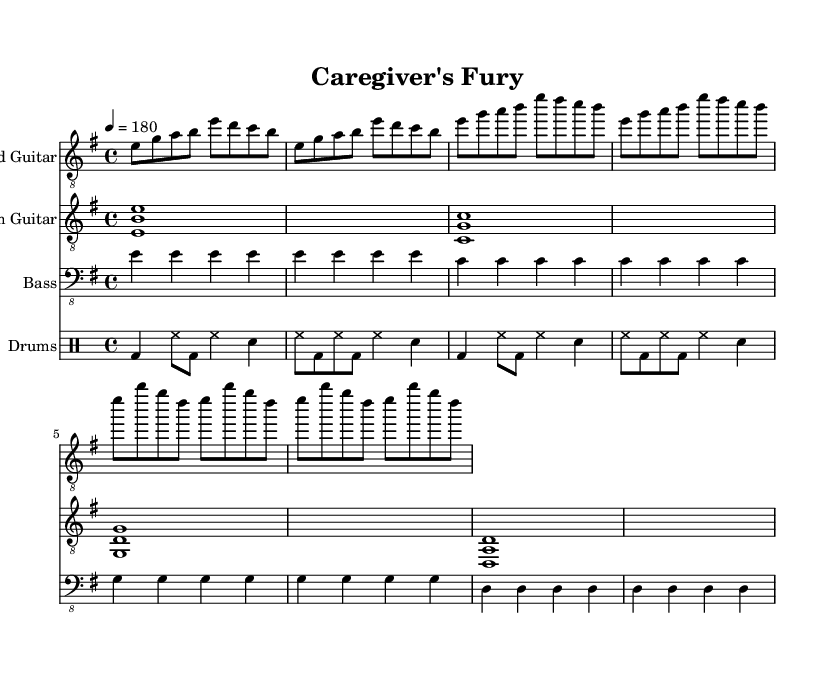What is the key signature of this music? The key signature is E minor, characterized by one sharp (F#). This is evident from the key indication in the global music block.
Answer: E minor What is the time signature of this music? The time signature is 4/4, as indicated in the global music block. This means there are four beats in each measure, and a quarter note receives one beat.
Answer: 4/4 What is the tempo of this piece? The tempo is marked at 180 beats per minute, which signifies a fast-paced performance. This is provided in the global music block as "4 = 180".
Answer: 180 How many measures are there in the lead guitar section? The lead guitar section contains a total of eight measures. This can be counted from the introductory section and two repeated verses, both of which are clearly organized into four measure segments.
Answer: Eight What is the dynamic characteristic of this piece based on its structure? The dynamic characteristic is generally high-energy and intense, evident from the fast tempo, repetitive riffs, and strong drum patterns typical of metal music. This expresses the cathartic emotion desired in high-energy metal songs.
Answer: High-energy What type of guitar technique is likely used in the rhythm guitar part? The rhythm guitar likely uses power chords, characterized by the intervals played, which is a common technique in metal music that adds to the heaviness and intensity of the sound. This can be inferred by the chord structure in the rhythm guitar part.
Answer: Power chords What is the significance of the drum part in this song? The drum part plays a crucial role in maintaining the energetic feel of the song, providing a steady driving beat that supports the rhythm; essential in metal genres where the drums often enhance the aggressive energy of the music.
Answer: Essential 